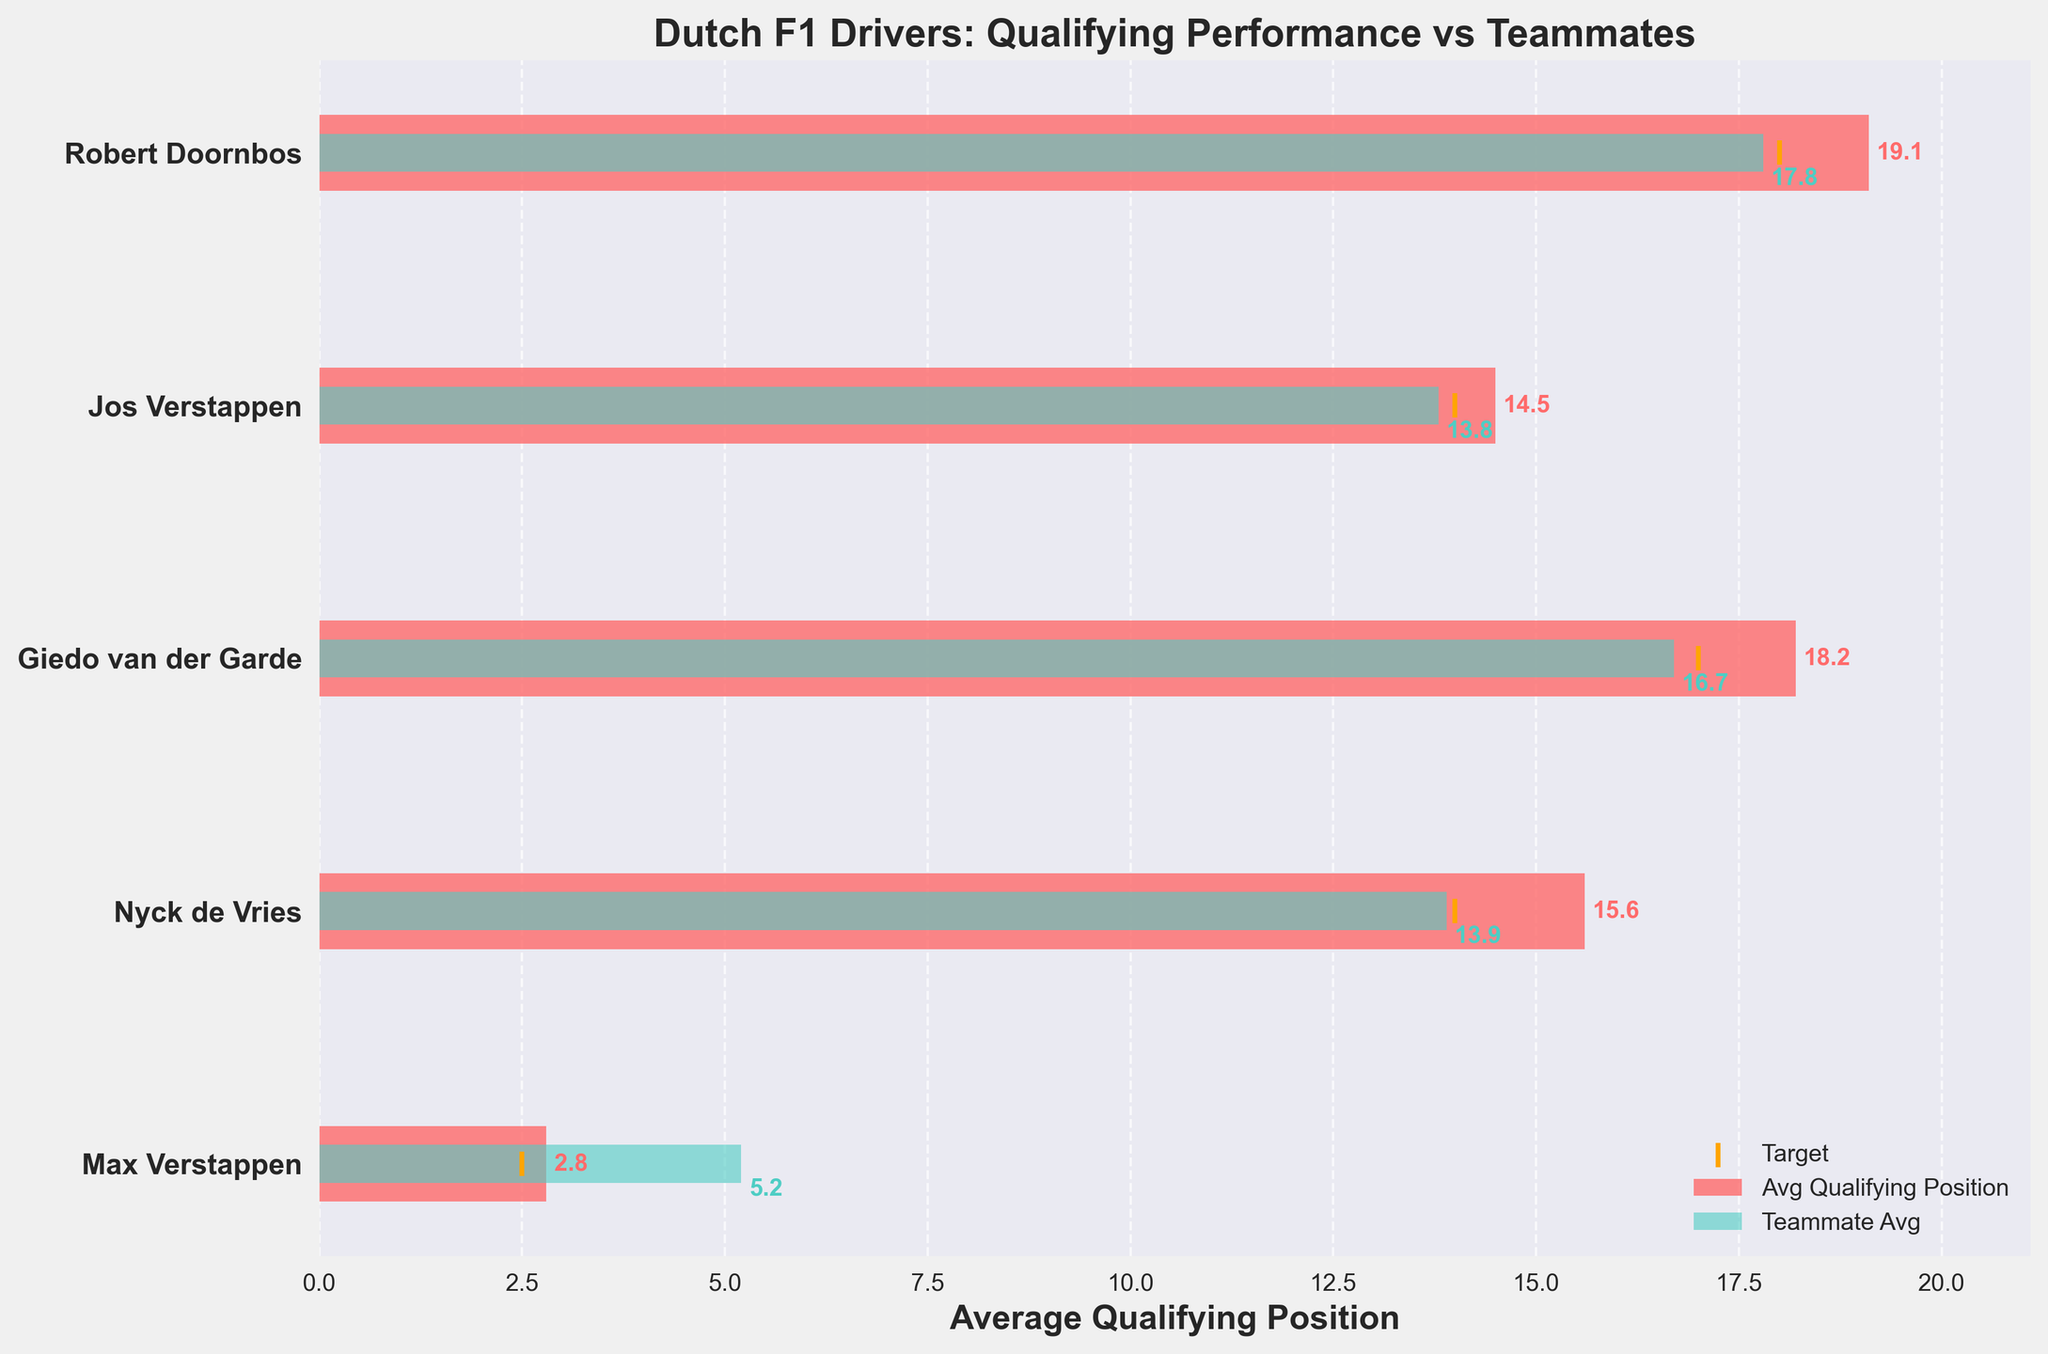What's the title of the figure? The title of a figure is usually displayed at the top. In this case, the title is clearly shown above the chart area.
Answer: Dutch F1 Drivers: Qualifying Performance vs Teammates How many Dutch F1 drivers are compared in the plot? By counting the number of distinct drivers listed on the y-axis, you can determine how many drivers are compared. There are five drivers listed.
Answer: 5 Which driver has the lowest average qualifying position? The lowest average qualifying position corresponds to the shortest bar in the chart. In this case, the bar for Max Verstappen is the shortest, indicating the lowest average.
Answer: Max Verstappen How many drivers had an average qualifying position below their target? To find this, check if the drivers' average qualifying position bars' ends are to the left of their respective target markers. Max Verstappen's average is below his target as its bar ends before the target line. Only Max Verstappen has an average qualifying position below his target.
Answer: 1 Which driver has the highest difference between their average qualifying position and their teammate's average? Calculate the differences visually by comparing the lengths of the drivers' bars with those of their teammates. Robert Doornbos has the highest difference, as the green bar (teammate) is significantly shorter than the red bar (driver).
Answer: Robert Doornbos Does any driver have a better average than their teammates but still not meet their target? For each driver, compare the red bar (driver) to the green bar (teammate) and the orange marker (target). Jos Verstappen has an average better than his teammate but not meeting the target, as his red bar is shorter than the green bar but ends before the target line.
Answer: Jos Verstappen What's the average qualifying position of Nyck de Vries' teammate compared to Nyck's position? Look at the lengths of the bars corresponding to Nyck de Vries and his teammate. Nyck's average is 15.6 and his teammate's average is 13.9. Subtract Nyck's position from his teammate's position: 15.6 - 13.9.
Answer: 1.7 spots worse Are there more drivers whose average qualifying positions are better than or worse than their teammates'? Count the number of red bars that are shorter than the green bars and compare it to the count of red bars that are longer. One driver (Jos Verstappen) has a better average than his teammate, while four drivers have worse averages.
Answer: More worse 